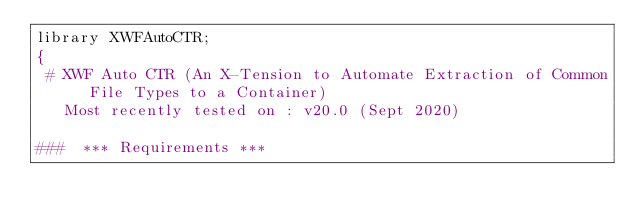Convert code to text. <code><loc_0><loc_0><loc_500><loc_500><_Pascal_>library XWFAutoCTR;
{
 # XWF Auto CTR (An X-Tension to Automate Extraction of Common File Types to a Container)
   Most recently tested on : v20.0 (Sept 2020)

###  *** Requirements ***</code> 